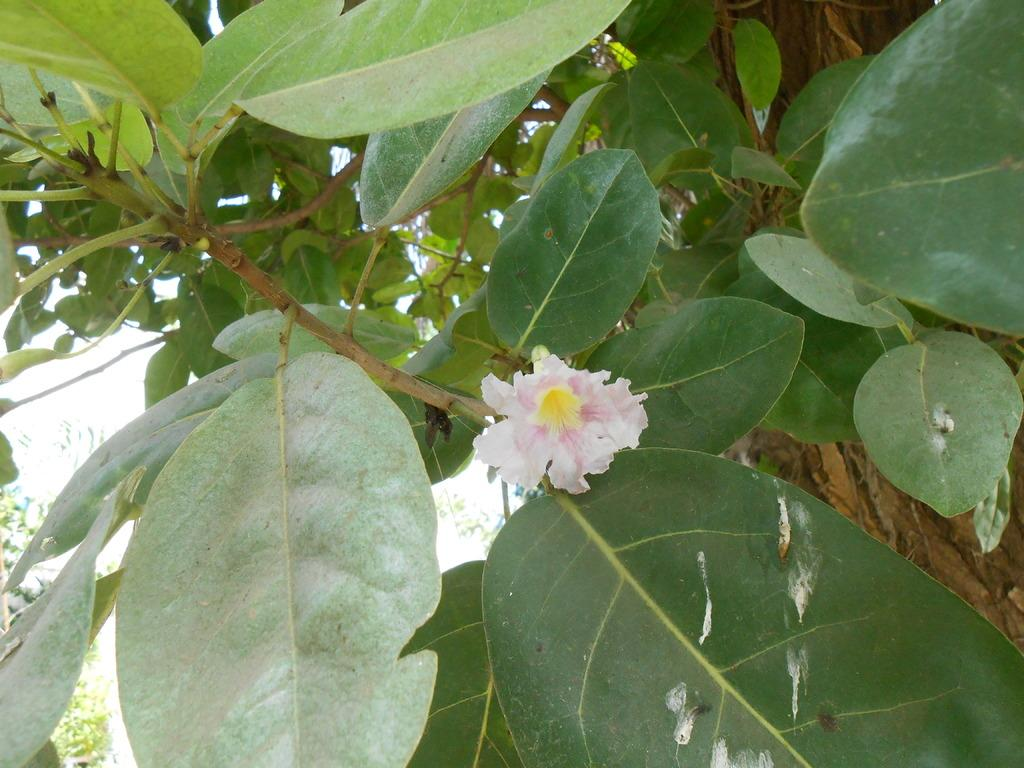What is present on the branch of the tree in the image? There is a flower on the branch of a tree in the image. How many fangs can be seen on the flower in the image? There are no fangs present on the flower in the image, as flowers do not have fangs. 